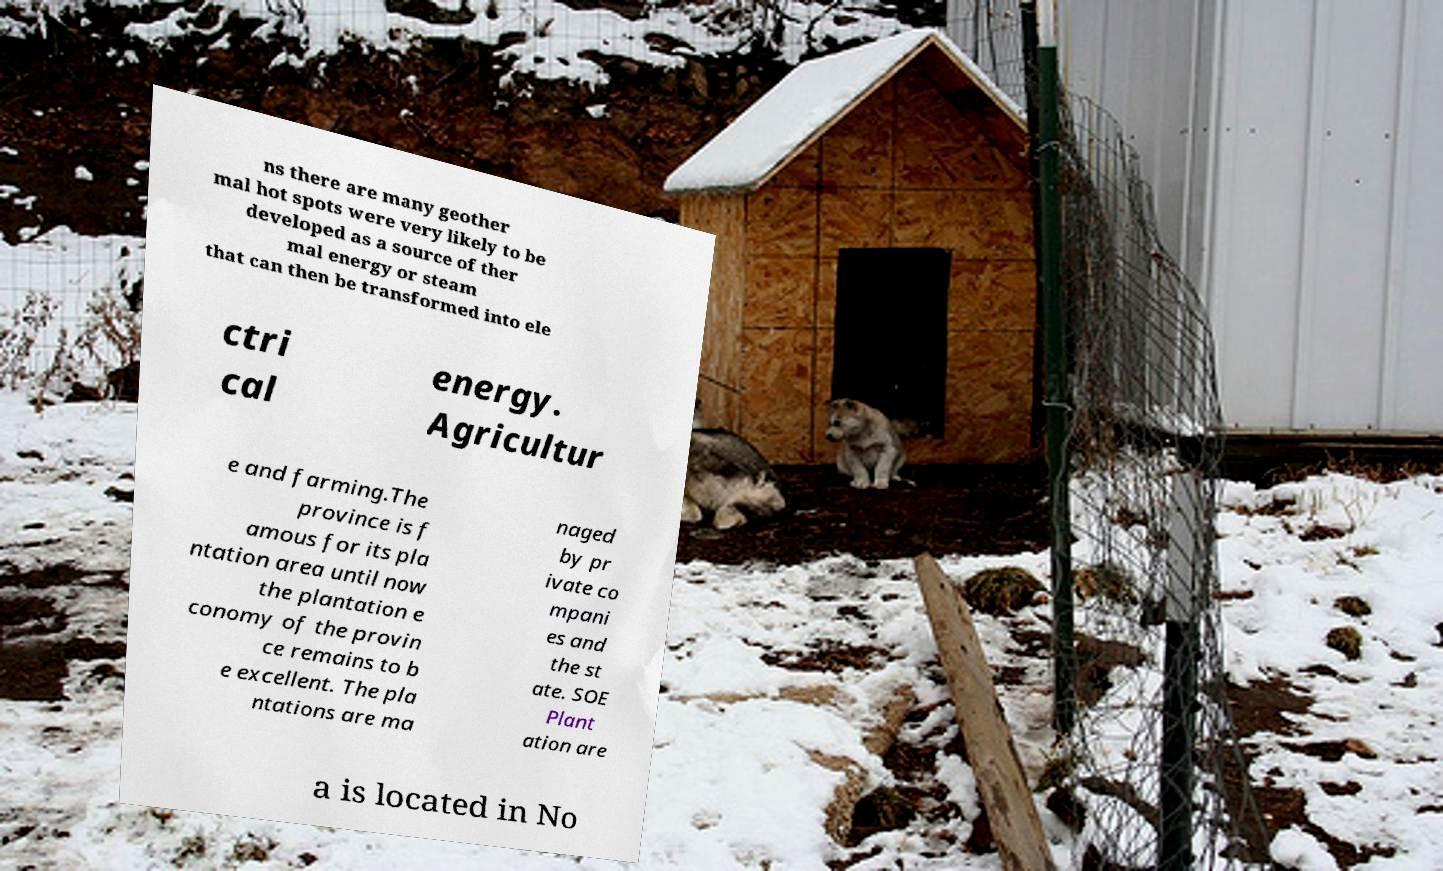Could you extract and type out the text from this image? ns there are many geother mal hot spots were very likely to be developed as a source of ther mal energy or steam that can then be transformed into ele ctri cal energy. Agricultur e and farming.The province is f amous for its pla ntation area until now the plantation e conomy of the provin ce remains to b e excellent. The pla ntations are ma naged by pr ivate co mpani es and the st ate. SOE Plant ation are a is located in No 